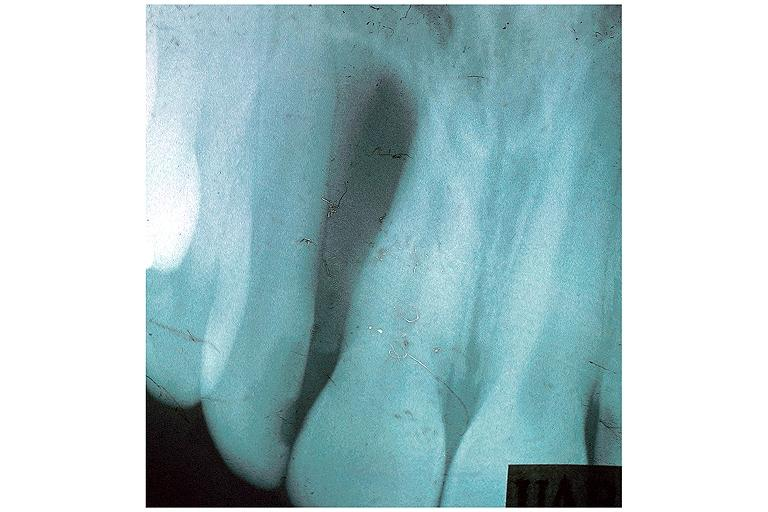s oral present?
Answer the question using a single word or phrase. Yes 